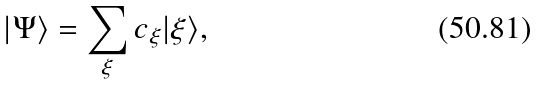<formula> <loc_0><loc_0><loc_500><loc_500>| \Psi \rangle = \sum _ { \xi } c _ { \xi } | \xi \rangle ,</formula> 